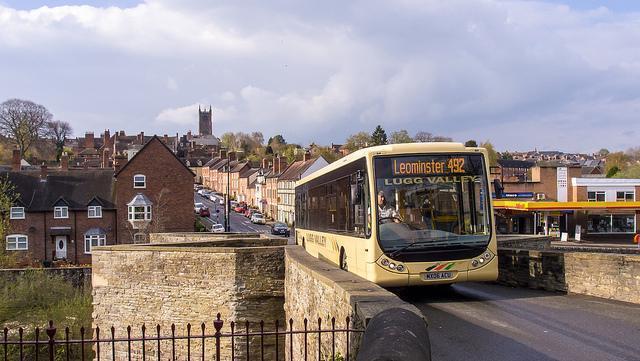How many oranges with barcode stickers?
Give a very brief answer. 0. 